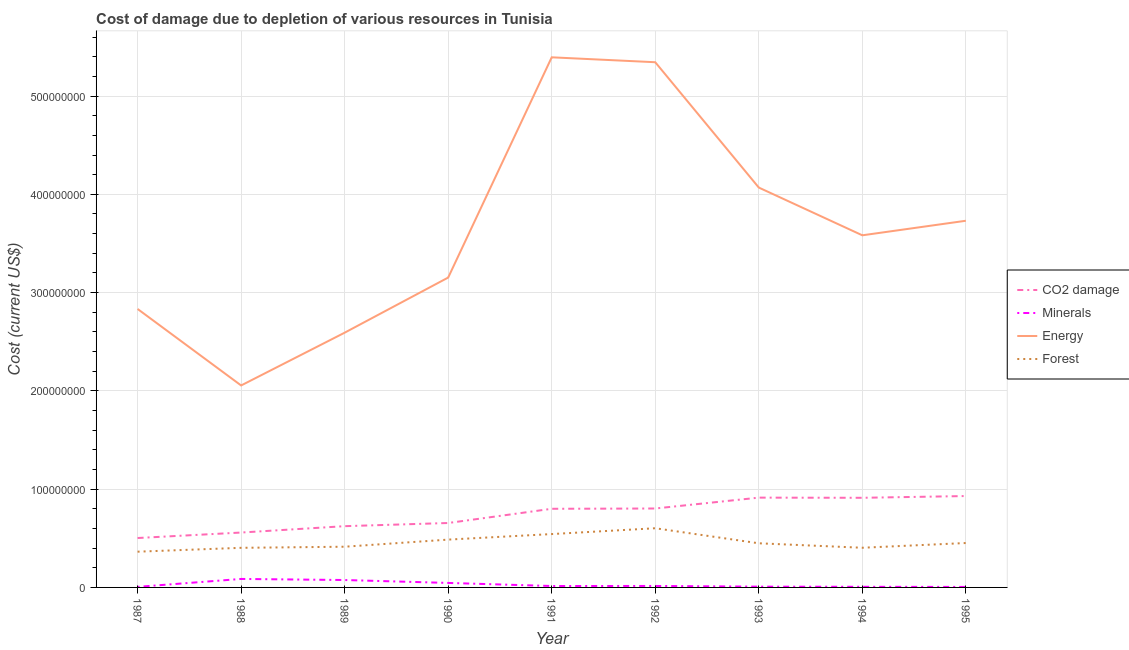Is the number of lines equal to the number of legend labels?
Give a very brief answer. Yes. What is the cost of damage due to depletion of coal in 1988?
Keep it short and to the point. 5.59e+07. Across all years, what is the maximum cost of damage due to depletion of energy?
Your answer should be very brief. 5.39e+08. Across all years, what is the minimum cost of damage due to depletion of coal?
Offer a very short reply. 5.03e+07. In which year was the cost of damage due to depletion of energy maximum?
Ensure brevity in your answer.  1991. In which year was the cost of damage due to depletion of forests minimum?
Provide a short and direct response. 1987. What is the total cost of damage due to depletion of minerals in the graph?
Give a very brief answer. 2.62e+07. What is the difference between the cost of damage due to depletion of coal in 1989 and that in 1995?
Make the answer very short. -3.07e+07. What is the difference between the cost of damage due to depletion of energy in 1989 and the cost of damage due to depletion of forests in 1993?
Provide a succinct answer. 2.14e+08. What is the average cost of damage due to depletion of forests per year?
Ensure brevity in your answer.  4.57e+07. In the year 1995, what is the difference between the cost of damage due to depletion of coal and cost of damage due to depletion of minerals?
Your answer should be compact. 9.25e+07. What is the ratio of the cost of damage due to depletion of minerals in 1989 to that in 1990?
Provide a short and direct response. 1.65. Is the cost of damage due to depletion of forests in 1987 less than that in 1992?
Your answer should be very brief. Yes. Is the difference between the cost of damage due to depletion of energy in 1992 and 1994 greater than the difference between the cost of damage due to depletion of coal in 1992 and 1994?
Make the answer very short. Yes. What is the difference between the highest and the second highest cost of damage due to depletion of coal?
Offer a very short reply. 1.61e+06. What is the difference between the highest and the lowest cost of damage due to depletion of forests?
Your answer should be compact. 2.39e+07. Is it the case that in every year, the sum of the cost of damage due to depletion of coal and cost of damage due to depletion of energy is greater than the sum of cost of damage due to depletion of minerals and cost of damage due to depletion of forests?
Your response must be concise. Yes. Is it the case that in every year, the sum of the cost of damage due to depletion of coal and cost of damage due to depletion of minerals is greater than the cost of damage due to depletion of energy?
Give a very brief answer. No. Does the cost of damage due to depletion of minerals monotonically increase over the years?
Your answer should be very brief. No. Is the cost of damage due to depletion of forests strictly less than the cost of damage due to depletion of energy over the years?
Provide a short and direct response. Yes. How many lines are there?
Ensure brevity in your answer.  4. What is the difference between two consecutive major ticks on the Y-axis?
Provide a short and direct response. 1.00e+08. Are the values on the major ticks of Y-axis written in scientific E-notation?
Your answer should be very brief. No. Does the graph contain grids?
Provide a succinct answer. Yes. How many legend labels are there?
Provide a succinct answer. 4. What is the title of the graph?
Make the answer very short. Cost of damage due to depletion of various resources in Tunisia . Does "France" appear as one of the legend labels in the graph?
Provide a succinct answer. No. What is the label or title of the X-axis?
Make the answer very short. Year. What is the label or title of the Y-axis?
Your answer should be very brief. Cost (current US$). What is the Cost (current US$) in CO2 damage in 1987?
Provide a succinct answer. 5.03e+07. What is the Cost (current US$) in Minerals in 1987?
Make the answer very short. 5.67e+05. What is the Cost (current US$) in Energy in 1987?
Provide a succinct answer. 2.83e+08. What is the Cost (current US$) in Forest in 1987?
Your answer should be compact. 3.64e+07. What is the Cost (current US$) in CO2 damage in 1988?
Provide a succinct answer. 5.59e+07. What is the Cost (current US$) of Minerals in 1988?
Offer a terse response. 8.63e+06. What is the Cost (current US$) in Energy in 1988?
Your response must be concise. 2.06e+08. What is the Cost (current US$) of Forest in 1988?
Your response must be concise. 4.03e+07. What is the Cost (current US$) of CO2 damage in 1989?
Offer a very short reply. 6.23e+07. What is the Cost (current US$) of Minerals in 1989?
Provide a succinct answer. 7.53e+06. What is the Cost (current US$) in Energy in 1989?
Your answer should be very brief. 2.59e+08. What is the Cost (current US$) of Forest in 1989?
Your answer should be very brief. 4.14e+07. What is the Cost (current US$) of CO2 damage in 1990?
Offer a very short reply. 6.56e+07. What is the Cost (current US$) of Minerals in 1990?
Offer a terse response. 4.58e+06. What is the Cost (current US$) in Energy in 1990?
Your response must be concise. 3.15e+08. What is the Cost (current US$) in Forest in 1990?
Offer a terse response. 4.87e+07. What is the Cost (current US$) of CO2 damage in 1991?
Your answer should be compact. 8.00e+07. What is the Cost (current US$) in Minerals in 1991?
Keep it short and to the point. 1.44e+06. What is the Cost (current US$) in Energy in 1991?
Ensure brevity in your answer.  5.39e+08. What is the Cost (current US$) of Forest in 1991?
Your answer should be very brief. 5.43e+07. What is the Cost (current US$) in CO2 damage in 1992?
Make the answer very short. 8.03e+07. What is the Cost (current US$) in Minerals in 1992?
Make the answer very short. 1.50e+06. What is the Cost (current US$) of Energy in 1992?
Provide a short and direct response. 5.34e+08. What is the Cost (current US$) in Forest in 1992?
Keep it short and to the point. 6.02e+07. What is the Cost (current US$) in CO2 damage in 1993?
Your answer should be compact. 9.14e+07. What is the Cost (current US$) of Minerals in 1993?
Give a very brief answer. 7.94e+05. What is the Cost (current US$) of Energy in 1993?
Offer a very short reply. 4.07e+08. What is the Cost (current US$) in Forest in 1993?
Ensure brevity in your answer.  4.49e+07. What is the Cost (current US$) of CO2 damage in 1994?
Your answer should be compact. 9.12e+07. What is the Cost (current US$) of Minerals in 1994?
Make the answer very short. 6.46e+05. What is the Cost (current US$) in Energy in 1994?
Offer a very short reply. 3.58e+08. What is the Cost (current US$) in Forest in 1994?
Offer a very short reply. 4.04e+07. What is the Cost (current US$) of CO2 damage in 1995?
Your answer should be compact. 9.30e+07. What is the Cost (current US$) of Minerals in 1995?
Ensure brevity in your answer.  5.07e+05. What is the Cost (current US$) of Energy in 1995?
Provide a succinct answer. 3.73e+08. What is the Cost (current US$) of Forest in 1995?
Offer a terse response. 4.52e+07. Across all years, what is the maximum Cost (current US$) in CO2 damage?
Your response must be concise. 9.30e+07. Across all years, what is the maximum Cost (current US$) of Minerals?
Keep it short and to the point. 8.63e+06. Across all years, what is the maximum Cost (current US$) in Energy?
Ensure brevity in your answer.  5.39e+08. Across all years, what is the maximum Cost (current US$) of Forest?
Ensure brevity in your answer.  6.02e+07. Across all years, what is the minimum Cost (current US$) in CO2 damage?
Your response must be concise. 5.03e+07. Across all years, what is the minimum Cost (current US$) in Minerals?
Your response must be concise. 5.07e+05. Across all years, what is the minimum Cost (current US$) of Energy?
Make the answer very short. 2.06e+08. Across all years, what is the minimum Cost (current US$) of Forest?
Your answer should be very brief. 3.64e+07. What is the total Cost (current US$) of CO2 damage in the graph?
Provide a short and direct response. 6.70e+08. What is the total Cost (current US$) of Minerals in the graph?
Give a very brief answer. 2.62e+07. What is the total Cost (current US$) of Energy in the graph?
Offer a terse response. 3.28e+09. What is the total Cost (current US$) in Forest in the graph?
Provide a short and direct response. 4.12e+08. What is the difference between the Cost (current US$) of CO2 damage in 1987 and that in 1988?
Give a very brief answer. -5.58e+06. What is the difference between the Cost (current US$) of Minerals in 1987 and that in 1988?
Provide a succinct answer. -8.07e+06. What is the difference between the Cost (current US$) of Energy in 1987 and that in 1988?
Your response must be concise. 7.78e+07. What is the difference between the Cost (current US$) of Forest in 1987 and that in 1988?
Give a very brief answer. -3.94e+06. What is the difference between the Cost (current US$) in CO2 damage in 1987 and that in 1989?
Make the answer very short. -1.21e+07. What is the difference between the Cost (current US$) in Minerals in 1987 and that in 1989?
Make the answer very short. -6.97e+06. What is the difference between the Cost (current US$) of Energy in 1987 and that in 1989?
Keep it short and to the point. 2.41e+07. What is the difference between the Cost (current US$) of Forest in 1987 and that in 1989?
Your response must be concise. -5.05e+06. What is the difference between the Cost (current US$) of CO2 damage in 1987 and that in 1990?
Provide a short and direct response. -1.53e+07. What is the difference between the Cost (current US$) of Minerals in 1987 and that in 1990?
Your response must be concise. -4.01e+06. What is the difference between the Cost (current US$) in Energy in 1987 and that in 1990?
Provide a short and direct response. -3.19e+07. What is the difference between the Cost (current US$) of Forest in 1987 and that in 1990?
Make the answer very short. -1.23e+07. What is the difference between the Cost (current US$) of CO2 damage in 1987 and that in 1991?
Make the answer very short. -2.97e+07. What is the difference between the Cost (current US$) in Minerals in 1987 and that in 1991?
Your response must be concise. -8.71e+05. What is the difference between the Cost (current US$) in Energy in 1987 and that in 1991?
Give a very brief answer. -2.56e+08. What is the difference between the Cost (current US$) of Forest in 1987 and that in 1991?
Provide a succinct answer. -1.79e+07. What is the difference between the Cost (current US$) of CO2 damage in 1987 and that in 1992?
Keep it short and to the point. -3.00e+07. What is the difference between the Cost (current US$) in Minerals in 1987 and that in 1992?
Give a very brief answer. -9.30e+05. What is the difference between the Cost (current US$) of Energy in 1987 and that in 1992?
Ensure brevity in your answer.  -2.51e+08. What is the difference between the Cost (current US$) in Forest in 1987 and that in 1992?
Offer a very short reply. -2.39e+07. What is the difference between the Cost (current US$) of CO2 damage in 1987 and that in 1993?
Give a very brief answer. -4.11e+07. What is the difference between the Cost (current US$) in Minerals in 1987 and that in 1993?
Make the answer very short. -2.27e+05. What is the difference between the Cost (current US$) of Energy in 1987 and that in 1993?
Ensure brevity in your answer.  -1.24e+08. What is the difference between the Cost (current US$) of Forest in 1987 and that in 1993?
Your answer should be very brief. -8.55e+06. What is the difference between the Cost (current US$) of CO2 damage in 1987 and that in 1994?
Offer a terse response. -4.09e+07. What is the difference between the Cost (current US$) in Minerals in 1987 and that in 1994?
Offer a terse response. -7.91e+04. What is the difference between the Cost (current US$) of Energy in 1987 and that in 1994?
Your answer should be very brief. -7.49e+07. What is the difference between the Cost (current US$) in Forest in 1987 and that in 1994?
Provide a succinct answer. -4.00e+06. What is the difference between the Cost (current US$) in CO2 damage in 1987 and that in 1995?
Keep it short and to the point. -4.27e+07. What is the difference between the Cost (current US$) of Minerals in 1987 and that in 1995?
Make the answer very short. 5.98e+04. What is the difference between the Cost (current US$) in Energy in 1987 and that in 1995?
Ensure brevity in your answer.  -8.97e+07. What is the difference between the Cost (current US$) of Forest in 1987 and that in 1995?
Give a very brief answer. -8.82e+06. What is the difference between the Cost (current US$) in CO2 damage in 1988 and that in 1989?
Give a very brief answer. -6.48e+06. What is the difference between the Cost (current US$) of Minerals in 1988 and that in 1989?
Make the answer very short. 1.10e+06. What is the difference between the Cost (current US$) of Energy in 1988 and that in 1989?
Provide a short and direct response. -5.37e+07. What is the difference between the Cost (current US$) of Forest in 1988 and that in 1989?
Provide a succinct answer. -1.12e+06. What is the difference between the Cost (current US$) of CO2 damage in 1988 and that in 1990?
Your answer should be compact. -9.71e+06. What is the difference between the Cost (current US$) of Minerals in 1988 and that in 1990?
Provide a succinct answer. 4.05e+06. What is the difference between the Cost (current US$) in Energy in 1988 and that in 1990?
Provide a succinct answer. -1.10e+08. What is the difference between the Cost (current US$) in Forest in 1988 and that in 1990?
Your response must be concise. -8.35e+06. What is the difference between the Cost (current US$) of CO2 damage in 1988 and that in 1991?
Ensure brevity in your answer.  -2.42e+07. What is the difference between the Cost (current US$) of Minerals in 1988 and that in 1991?
Your response must be concise. 7.19e+06. What is the difference between the Cost (current US$) in Energy in 1988 and that in 1991?
Your response must be concise. -3.34e+08. What is the difference between the Cost (current US$) in Forest in 1988 and that in 1991?
Your response must be concise. -1.40e+07. What is the difference between the Cost (current US$) in CO2 damage in 1988 and that in 1992?
Your answer should be very brief. -2.45e+07. What is the difference between the Cost (current US$) of Minerals in 1988 and that in 1992?
Keep it short and to the point. 7.14e+06. What is the difference between the Cost (current US$) in Energy in 1988 and that in 1992?
Provide a short and direct response. -3.29e+08. What is the difference between the Cost (current US$) in Forest in 1988 and that in 1992?
Provide a short and direct response. -1.99e+07. What is the difference between the Cost (current US$) in CO2 damage in 1988 and that in 1993?
Make the answer very short. -3.55e+07. What is the difference between the Cost (current US$) in Minerals in 1988 and that in 1993?
Give a very brief answer. 7.84e+06. What is the difference between the Cost (current US$) in Energy in 1988 and that in 1993?
Ensure brevity in your answer.  -2.01e+08. What is the difference between the Cost (current US$) in Forest in 1988 and that in 1993?
Provide a succinct answer. -4.61e+06. What is the difference between the Cost (current US$) of CO2 damage in 1988 and that in 1994?
Provide a short and direct response. -3.54e+07. What is the difference between the Cost (current US$) in Minerals in 1988 and that in 1994?
Keep it short and to the point. 7.99e+06. What is the difference between the Cost (current US$) of Energy in 1988 and that in 1994?
Your answer should be very brief. -1.53e+08. What is the difference between the Cost (current US$) in Forest in 1988 and that in 1994?
Provide a succinct answer. -6.18e+04. What is the difference between the Cost (current US$) of CO2 damage in 1988 and that in 1995?
Offer a very short reply. -3.71e+07. What is the difference between the Cost (current US$) of Minerals in 1988 and that in 1995?
Your answer should be very brief. 8.13e+06. What is the difference between the Cost (current US$) in Energy in 1988 and that in 1995?
Your answer should be very brief. -1.68e+08. What is the difference between the Cost (current US$) of Forest in 1988 and that in 1995?
Give a very brief answer. -4.88e+06. What is the difference between the Cost (current US$) of CO2 damage in 1989 and that in 1990?
Ensure brevity in your answer.  -3.23e+06. What is the difference between the Cost (current US$) of Minerals in 1989 and that in 1990?
Your answer should be very brief. 2.96e+06. What is the difference between the Cost (current US$) in Energy in 1989 and that in 1990?
Offer a terse response. -5.61e+07. What is the difference between the Cost (current US$) of Forest in 1989 and that in 1990?
Offer a very short reply. -7.24e+06. What is the difference between the Cost (current US$) of CO2 damage in 1989 and that in 1991?
Your response must be concise. -1.77e+07. What is the difference between the Cost (current US$) in Minerals in 1989 and that in 1991?
Provide a succinct answer. 6.10e+06. What is the difference between the Cost (current US$) in Energy in 1989 and that in 1991?
Provide a succinct answer. -2.80e+08. What is the difference between the Cost (current US$) in Forest in 1989 and that in 1991?
Your answer should be very brief. -1.29e+07. What is the difference between the Cost (current US$) of CO2 damage in 1989 and that in 1992?
Make the answer very short. -1.80e+07. What is the difference between the Cost (current US$) in Minerals in 1989 and that in 1992?
Make the answer very short. 6.04e+06. What is the difference between the Cost (current US$) in Energy in 1989 and that in 1992?
Your answer should be very brief. -2.75e+08. What is the difference between the Cost (current US$) in Forest in 1989 and that in 1992?
Make the answer very short. -1.88e+07. What is the difference between the Cost (current US$) in CO2 damage in 1989 and that in 1993?
Provide a succinct answer. -2.90e+07. What is the difference between the Cost (current US$) in Minerals in 1989 and that in 1993?
Offer a very short reply. 6.74e+06. What is the difference between the Cost (current US$) of Energy in 1989 and that in 1993?
Give a very brief answer. -1.48e+08. What is the difference between the Cost (current US$) in Forest in 1989 and that in 1993?
Your answer should be compact. -3.50e+06. What is the difference between the Cost (current US$) of CO2 damage in 1989 and that in 1994?
Make the answer very short. -2.89e+07. What is the difference between the Cost (current US$) of Minerals in 1989 and that in 1994?
Provide a succinct answer. 6.89e+06. What is the difference between the Cost (current US$) of Energy in 1989 and that in 1994?
Offer a terse response. -9.91e+07. What is the difference between the Cost (current US$) in Forest in 1989 and that in 1994?
Offer a very short reply. 1.05e+06. What is the difference between the Cost (current US$) in CO2 damage in 1989 and that in 1995?
Make the answer very short. -3.07e+07. What is the difference between the Cost (current US$) of Minerals in 1989 and that in 1995?
Give a very brief answer. 7.03e+06. What is the difference between the Cost (current US$) of Energy in 1989 and that in 1995?
Provide a succinct answer. -1.14e+08. What is the difference between the Cost (current US$) of Forest in 1989 and that in 1995?
Offer a very short reply. -3.77e+06. What is the difference between the Cost (current US$) in CO2 damage in 1990 and that in 1991?
Provide a short and direct response. -1.45e+07. What is the difference between the Cost (current US$) of Minerals in 1990 and that in 1991?
Offer a very short reply. 3.14e+06. What is the difference between the Cost (current US$) of Energy in 1990 and that in 1991?
Offer a very short reply. -2.24e+08. What is the difference between the Cost (current US$) of Forest in 1990 and that in 1991?
Give a very brief answer. -5.64e+06. What is the difference between the Cost (current US$) in CO2 damage in 1990 and that in 1992?
Give a very brief answer. -1.48e+07. What is the difference between the Cost (current US$) in Minerals in 1990 and that in 1992?
Offer a terse response. 3.08e+06. What is the difference between the Cost (current US$) of Energy in 1990 and that in 1992?
Your answer should be compact. -2.19e+08. What is the difference between the Cost (current US$) in Forest in 1990 and that in 1992?
Ensure brevity in your answer.  -1.16e+07. What is the difference between the Cost (current US$) in CO2 damage in 1990 and that in 1993?
Keep it short and to the point. -2.58e+07. What is the difference between the Cost (current US$) in Minerals in 1990 and that in 1993?
Offer a terse response. 3.78e+06. What is the difference between the Cost (current US$) of Energy in 1990 and that in 1993?
Your answer should be compact. -9.16e+07. What is the difference between the Cost (current US$) of Forest in 1990 and that in 1993?
Offer a very short reply. 3.74e+06. What is the difference between the Cost (current US$) in CO2 damage in 1990 and that in 1994?
Ensure brevity in your answer.  -2.56e+07. What is the difference between the Cost (current US$) in Minerals in 1990 and that in 1994?
Ensure brevity in your answer.  3.93e+06. What is the difference between the Cost (current US$) of Energy in 1990 and that in 1994?
Your answer should be very brief. -4.30e+07. What is the difference between the Cost (current US$) of Forest in 1990 and that in 1994?
Keep it short and to the point. 8.29e+06. What is the difference between the Cost (current US$) of CO2 damage in 1990 and that in 1995?
Ensure brevity in your answer.  -2.74e+07. What is the difference between the Cost (current US$) in Minerals in 1990 and that in 1995?
Your answer should be very brief. 4.07e+06. What is the difference between the Cost (current US$) of Energy in 1990 and that in 1995?
Make the answer very short. -5.78e+07. What is the difference between the Cost (current US$) of Forest in 1990 and that in 1995?
Your answer should be very brief. 3.47e+06. What is the difference between the Cost (current US$) in CO2 damage in 1991 and that in 1992?
Provide a succinct answer. -2.96e+05. What is the difference between the Cost (current US$) of Minerals in 1991 and that in 1992?
Your response must be concise. -5.93e+04. What is the difference between the Cost (current US$) in Energy in 1991 and that in 1992?
Your answer should be very brief. 5.01e+06. What is the difference between the Cost (current US$) in Forest in 1991 and that in 1992?
Your answer should be very brief. -5.92e+06. What is the difference between the Cost (current US$) of CO2 damage in 1991 and that in 1993?
Your answer should be very brief. -1.14e+07. What is the difference between the Cost (current US$) of Minerals in 1991 and that in 1993?
Provide a short and direct response. 6.44e+05. What is the difference between the Cost (current US$) in Energy in 1991 and that in 1993?
Offer a terse response. 1.33e+08. What is the difference between the Cost (current US$) in Forest in 1991 and that in 1993?
Give a very brief answer. 9.38e+06. What is the difference between the Cost (current US$) of CO2 damage in 1991 and that in 1994?
Offer a terse response. -1.12e+07. What is the difference between the Cost (current US$) in Minerals in 1991 and that in 1994?
Make the answer very short. 7.91e+05. What is the difference between the Cost (current US$) of Energy in 1991 and that in 1994?
Your answer should be compact. 1.81e+08. What is the difference between the Cost (current US$) of Forest in 1991 and that in 1994?
Provide a succinct answer. 1.39e+07. What is the difference between the Cost (current US$) of CO2 damage in 1991 and that in 1995?
Your answer should be very brief. -1.30e+07. What is the difference between the Cost (current US$) in Minerals in 1991 and that in 1995?
Your answer should be compact. 9.30e+05. What is the difference between the Cost (current US$) of Energy in 1991 and that in 1995?
Give a very brief answer. 1.66e+08. What is the difference between the Cost (current US$) in Forest in 1991 and that in 1995?
Your answer should be very brief. 9.11e+06. What is the difference between the Cost (current US$) in CO2 damage in 1992 and that in 1993?
Your answer should be very brief. -1.11e+07. What is the difference between the Cost (current US$) of Minerals in 1992 and that in 1993?
Offer a very short reply. 7.03e+05. What is the difference between the Cost (current US$) in Energy in 1992 and that in 1993?
Your answer should be very brief. 1.28e+08. What is the difference between the Cost (current US$) in Forest in 1992 and that in 1993?
Ensure brevity in your answer.  1.53e+07. What is the difference between the Cost (current US$) of CO2 damage in 1992 and that in 1994?
Provide a short and direct response. -1.09e+07. What is the difference between the Cost (current US$) in Minerals in 1992 and that in 1994?
Keep it short and to the point. 8.51e+05. What is the difference between the Cost (current US$) in Energy in 1992 and that in 1994?
Offer a very short reply. 1.76e+08. What is the difference between the Cost (current US$) of Forest in 1992 and that in 1994?
Make the answer very short. 1.99e+07. What is the difference between the Cost (current US$) of CO2 damage in 1992 and that in 1995?
Your answer should be compact. -1.27e+07. What is the difference between the Cost (current US$) of Minerals in 1992 and that in 1995?
Make the answer very short. 9.90e+05. What is the difference between the Cost (current US$) in Energy in 1992 and that in 1995?
Make the answer very short. 1.61e+08. What is the difference between the Cost (current US$) in Forest in 1992 and that in 1995?
Make the answer very short. 1.50e+07. What is the difference between the Cost (current US$) of CO2 damage in 1993 and that in 1994?
Make the answer very short. 1.69e+05. What is the difference between the Cost (current US$) in Minerals in 1993 and that in 1994?
Keep it short and to the point. 1.48e+05. What is the difference between the Cost (current US$) in Energy in 1993 and that in 1994?
Your answer should be compact. 4.86e+07. What is the difference between the Cost (current US$) of Forest in 1993 and that in 1994?
Provide a succinct answer. 4.55e+06. What is the difference between the Cost (current US$) of CO2 damage in 1993 and that in 1995?
Ensure brevity in your answer.  -1.61e+06. What is the difference between the Cost (current US$) in Minerals in 1993 and that in 1995?
Provide a short and direct response. 2.87e+05. What is the difference between the Cost (current US$) of Energy in 1993 and that in 1995?
Keep it short and to the point. 3.38e+07. What is the difference between the Cost (current US$) of Forest in 1993 and that in 1995?
Make the answer very short. -2.73e+05. What is the difference between the Cost (current US$) of CO2 damage in 1994 and that in 1995?
Ensure brevity in your answer.  -1.78e+06. What is the difference between the Cost (current US$) in Minerals in 1994 and that in 1995?
Your response must be concise. 1.39e+05. What is the difference between the Cost (current US$) in Energy in 1994 and that in 1995?
Provide a succinct answer. -1.48e+07. What is the difference between the Cost (current US$) in Forest in 1994 and that in 1995?
Offer a very short reply. -4.82e+06. What is the difference between the Cost (current US$) of CO2 damage in 1987 and the Cost (current US$) of Minerals in 1988?
Provide a short and direct response. 4.16e+07. What is the difference between the Cost (current US$) in CO2 damage in 1987 and the Cost (current US$) in Energy in 1988?
Give a very brief answer. -1.55e+08. What is the difference between the Cost (current US$) of CO2 damage in 1987 and the Cost (current US$) of Forest in 1988?
Keep it short and to the point. 9.97e+06. What is the difference between the Cost (current US$) of Minerals in 1987 and the Cost (current US$) of Energy in 1988?
Your answer should be very brief. -2.05e+08. What is the difference between the Cost (current US$) of Minerals in 1987 and the Cost (current US$) of Forest in 1988?
Give a very brief answer. -3.97e+07. What is the difference between the Cost (current US$) in Energy in 1987 and the Cost (current US$) in Forest in 1988?
Offer a terse response. 2.43e+08. What is the difference between the Cost (current US$) in CO2 damage in 1987 and the Cost (current US$) in Minerals in 1989?
Provide a succinct answer. 4.27e+07. What is the difference between the Cost (current US$) in CO2 damage in 1987 and the Cost (current US$) in Energy in 1989?
Provide a succinct answer. -2.09e+08. What is the difference between the Cost (current US$) of CO2 damage in 1987 and the Cost (current US$) of Forest in 1989?
Make the answer very short. 8.85e+06. What is the difference between the Cost (current US$) in Minerals in 1987 and the Cost (current US$) in Energy in 1989?
Give a very brief answer. -2.59e+08. What is the difference between the Cost (current US$) in Minerals in 1987 and the Cost (current US$) in Forest in 1989?
Your answer should be compact. -4.09e+07. What is the difference between the Cost (current US$) of Energy in 1987 and the Cost (current US$) of Forest in 1989?
Your answer should be very brief. 2.42e+08. What is the difference between the Cost (current US$) in CO2 damage in 1987 and the Cost (current US$) in Minerals in 1990?
Ensure brevity in your answer.  4.57e+07. What is the difference between the Cost (current US$) in CO2 damage in 1987 and the Cost (current US$) in Energy in 1990?
Your answer should be compact. -2.65e+08. What is the difference between the Cost (current US$) of CO2 damage in 1987 and the Cost (current US$) of Forest in 1990?
Provide a short and direct response. 1.62e+06. What is the difference between the Cost (current US$) of Minerals in 1987 and the Cost (current US$) of Energy in 1990?
Offer a terse response. -3.15e+08. What is the difference between the Cost (current US$) of Minerals in 1987 and the Cost (current US$) of Forest in 1990?
Provide a succinct answer. -4.81e+07. What is the difference between the Cost (current US$) in Energy in 1987 and the Cost (current US$) in Forest in 1990?
Your response must be concise. 2.35e+08. What is the difference between the Cost (current US$) in CO2 damage in 1987 and the Cost (current US$) in Minerals in 1991?
Your answer should be compact. 4.88e+07. What is the difference between the Cost (current US$) of CO2 damage in 1987 and the Cost (current US$) of Energy in 1991?
Offer a terse response. -4.89e+08. What is the difference between the Cost (current US$) in CO2 damage in 1987 and the Cost (current US$) in Forest in 1991?
Offer a terse response. -4.02e+06. What is the difference between the Cost (current US$) of Minerals in 1987 and the Cost (current US$) of Energy in 1991?
Keep it short and to the point. -5.39e+08. What is the difference between the Cost (current US$) in Minerals in 1987 and the Cost (current US$) in Forest in 1991?
Your response must be concise. -5.37e+07. What is the difference between the Cost (current US$) in Energy in 1987 and the Cost (current US$) in Forest in 1991?
Offer a very short reply. 2.29e+08. What is the difference between the Cost (current US$) in CO2 damage in 1987 and the Cost (current US$) in Minerals in 1992?
Make the answer very short. 4.88e+07. What is the difference between the Cost (current US$) in CO2 damage in 1987 and the Cost (current US$) in Energy in 1992?
Provide a succinct answer. -4.84e+08. What is the difference between the Cost (current US$) in CO2 damage in 1987 and the Cost (current US$) in Forest in 1992?
Provide a succinct answer. -9.95e+06. What is the difference between the Cost (current US$) in Minerals in 1987 and the Cost (current US$) in Energy in 1992?
Your answer should be very brief. -5.34e+08. What is the difference between the Cost (current US$) in Minerals in 1987 and the Cost (current US$) in Forest in 1992?
Provide a succinct answer. -5.97e+07. What is the difference between the Cost (current US$) of Energy in 1987 and the Cost (current US$) of Forest in 1992?
Provide a succinct answer. 2.23e+08. What is the difference between the Cost (current US$) of CO2 damage in 1987 and the Cost (current US$) of Minerals in 1993?
Give a very brief answer. 4.95e+07. What is the difference between the Cost (current US$) in CO2 damage in 1987 and the Cost (current US$) in Energy in 1993?
Your answer should be compact. -3.57e+08. What is the difference between the Cost (current US$) in CO2 damage in 1987 and the Cost (current US$) in Forest in 1993?
Offer a very short reply. 5.36e+06. What is the difference between the Cost (current US$) in Minerals in 1987 and the Cost (current US$) in Energy in 1993?
Provide a short and direct response. -4.06e+08. What is the difference between the Cost (current US$) in Minerals in 1987 and the Cost (current US$) in Forest in 1993?
Provide a succinct answer. -4.43e+07. What is the difference between the Cost (current US$) of Energy in 1987 and the Cost (current US$) of Forest in 1993?
Your answer should be very brief. 2.38e+08. What is the difference between the Cost (current US$) in CO2 damage in 1987 and the Cost (current US$) in Minerals in 1994?
Your answer should be very brief. 4.96e+07. What is the difference between the Cost (current US$) of CO2 damage in 1987 and the Cost (current US$) of Energy in 1994?
Provide a short and direct response. -3.08e+08. What is the difference between the Cost (current US$) of CO2 damage in 1987 and the Cost (current US$) of Forest in 1994?
Give a very brief answer. 9.91e+06. What is the difference between the Cost (current US$) of Minerals in 1987 and the Cost (current US$) of Energy in 1994?
Your answer should be very brief. -3.58e+08. What is the difference between the Cost (current US$) in Minerals in 1987 and the Cost (current US$) in Forest in 1994?
Your answer should be compact. -3.98e+07. What is the difference between the Cost (current US$) in Energy in 1987 and the Cost (current US$) in Forest in 1994?
Provide a short and direct response. 2.43e+08. What is the difference between the Cost (current US$) in CO2 damage in 1987 and the Cost (current US$) in Minerals in 1995?
Provide a short and direct response. 4.98e+07. What is the difference between the Cost (current US$) in CO2 damage in 1987 and the Cost (current US$) in Energy in 1995?
Offer a very short reply. -3.23e+08. What is the difference between the Cost (current US$) in CO2 damage in 1987 and the Cost (current US$) in Forest in 1995?
Give a very brief answer. 5.09e+06. What is the difference between the Cost (current US$) in Minerals in 1987 and the Cost (current US$) in Energy in 1995?
Offer a terse response. -3.73e+08. What is the difference between the Cost (current US$) of Minerals in 1987 and the Cost (current US$) of Forest in 1995?
Give a very brief answer. -4.46e+07. What is the difference between the Cost (current US$) in Energy in 1987 and the Cost (current US$) in Forest in 1995?
Offer a very short reply. 2.38e+08. What is the difference between the Cost (current US$) in CO2 damage in 1988 and the Cost (current US$) in Minerals in 1989?
Give a very brief answer. 4.83e+07. What is the difference between the Cost (current US$) of CO2 damage in 1988 and the Cost (current US$) of Energy in 1989?
Provide a short and direct response. -2.03e+08. What is the difference between the Cost (current US$) of CO2 damage in 1988 and the Cost (current US$) of Forest in 1989?
Provide a short and direct response. 1.44e+07. What is the difference between the Cost (current US$) of Minerals in 1988 and the Cost (current US$) of Energy in 1989?
Offer a very short reply. -2.51e+08. What is the difference between the Cost (current US$) in Minerals in 1988 and the Cost (current US$) in Forest in 1989?
Your response must be concise. -3.28e+07. What is the difference between the Cost (current US$) of Energy in 1988 and the Cost (current US$) of Forest in 1989?
Make the answer very short. 1.64e+08. What is the difference between the Cost (current US$) in CO2 damage in 1988 and the Cost (current US$) in Minerals in 1990?
Provide a short and direct response. 5.13e+07. What is the difference between the Cost (current US$) in CO2 damage in 1988 and the Cost (current US$) in Energy in 1990?
Provide a short and direct response. -2.59e+08. What is the difference between the Cost (current US$) of CO2 damage in 1988 and the Cost (current US$) of Forest in 1990?
Give a very brief answer. 7.19e+06. What is the difference between the Cost (current US$) of Minerals in 1988 and the Cost (current US$) of Energy in 1990?
Make the answer very short. -3.07e+08. What is the difference between the Cost (current US$) in Minerals in 1988 and the Cost (current US$) in Forest in 1990?
Ensure brevity in your answer.  -4.00e+07. What is the difference between the Cost (current US$) of Energy in 1988 and the Cost (current US$) of Forest in 1990?
Your answer should be compact. 1.57e+08. What is the difference between the Cost (current US$) in CO2 damage in 1988 and the Cost (current US$) in Minerals in 1991?
Provide a succinct answer. 5.44e+07. What is the difference between the Cost (current US$) of CO2 damage in 1988 and the Cost (current US$) of Energy in 1991?
Your answer should be compact. -4.84e+08. What is the difference between the Cost (current US$) in CO2 damage in 1988 and the Cost (current US$) in Forest in 1991?
Provide a short and direct response. 1.55e+06. What is the difference between the Cost (current US$) of Minerals in 1988 and the Cost (current US$) of Energy in 1991?
Provide a short and direct response. -5.31e+08. What is the difference between the Cost (current US$) of Minerals in 1988 and the Cost (current US$) of Forest in 1991?
Provide a short and direct response. -4.57e+07. What is the difference between the Cost (current US$) in Energy in 1988 and the Cost (current US$) in Forest in 1991?
Give a very brief answer. 1.51e+08. What is the difference between the Cost (current US$) in CO2 damage in 1988 and the Cost (current US$) in Minerals in 1992?
Your response must be concise. 5.44e+07. What is the difference between the Cost (current US$) of CO2 damage in 1988 and the Cost (current US$) of Energy in 1992?
Provide a short and direct response. -4.79e+08. What is the difference between the Cost (current US$) of CO2 damage in 1988 and the Cost (current US$) of Forest in 1992?
Provide a succinct answer. -4.37e+06. What is the difference between the Cost (current US$) of Minerals in 1988 and the Cost (current US$) of Energy in 1992?
Your answer should be compact. -5.26e+08. What is the difference between the Cost (current US$) in Minerals in 1988 and the Cost (current US$) in Forest in 1992?
Your answer should be compact. -5.16e+07. What is the difference between the Cost (current US$) in Energy in 1988 and the Cost (current US$) in Forest in 1992?
Give a very brief answer. 1.45e+08. What is the difference between the Cost (current US$) of CO2 damage in 1988 and the Cost (current US$) of Minerals in 1993?
Offer a terse response. 5.51e+07. What is the difference between the Cost (current US$) in CO2 damage in 1988 and the Cost (current US$) in Energy in 1993?
Your response must be concise. -3.51e+08. What is the difference between the Cost (current US$) of CO2 damage in 1988 and the Cost (current US$) of Forest in 1993?
Make the answer very short. 1.09e+07. What is the difference between the Cost (current US$) of Minerals in 1988 and the Cost (current US$) of Energy in 1993?
Give a very brief answer. -3.98e+08. What is the difference between the Cost (current US$) in Minerals in 1988 and the Cost (current US$) in Forest in 1993?
Offer a terse response. -3.63e+07. What is the difference between the Cost (current US$) of Energy in 1988 and the Cost (current US$) of Forest in 1993?
Your response must be concise. 1.61e+08. What is the difference between the Cost (current US$) in CO2 damage in 1988 and the Cost (current US$) in Minerals in 1994?
Your answer should be compact. 5.52e+07. What is the difference between the Cost (current US$) of CO2 damage in 1988 and the Cost (current US$) of Energy in 1994?
Make the answer very short. -3.02e+08. What is the difference between the Cost (current US$) in CO2 damage in 1988 and the Cost (current US$) in Forest in 1994?
Your response must be concise. 1.55e+07. What is the difference between the Cost (current US$) in Minerals in 1988 and the Cost (current US$) in Energy in 1994?
Your answer should be compact. -3.50e+08. What is the difference between the Cost (current US$) of Minerals in 1988 and the Cost (current US$) of Forest in 1994?
Your answer should be very brief. -3.17e+07. What is the difference between the Cost (current US$) of Energy in 1988 and the Cost (current US$) of Forest in 1994?
Your answer should be very brief. 1.65e+08. What is the difference between the Cost (current US$) in CO2 damage in 1988 and the Cost (current US$) in Minerals in 1995?
Your response must be concise. 5.53e+07. What is the difference between the Cost (current US$) of CO2 damage in 1988 and the Cost (current US$) of Energy in 1995?
Offer a terse response. -3.17e+08. What is the difference between the Cost (current US$) in CO2 damage in 1988 and the Cost (current US$) in Forest in 1995?
Ensure brevity in your answer.  1.07e+07. What is the difference between the Cost (current US$) in Minerals in 1988 and the Cost (current US$) in Energy in 1995?
Your response must be concise. -3.64e+08. What is the difference between the Cost (current US$) of Minerals in 1988 and the Cost (current US$) of Forest in 1995?
Your answer should be very brief. -3.66e+07. What is the difference between the Cost (current US$) of Energy in 1988 and the Cost (current US$) of Forest in 1995?
Give a very brief answer. 1.60e+08. What is the difference between the Cost (current US$) of CO2 damage in 1989 and the Cost (current US$) of Minerals in 1990?
Keep it short and to the point. 5.78e+07. What is the difference between the Cost (current US$) in CO2 damage in 1989 and the Cost (current US$) in Energy in 1990?
Make the answer very short. -2.53e+08. What is the difference between the Cost (current US$) of CO2 damage in 1989 and the Cost (current US$) of Forest in 1990?
Ensure brevity in your answer.  1.37e+07. What is the difference between the Cost (current US$) in Minerals in 1989 and the Cost (current US$) in Energy in 1990?
Make the answer very short. -3.08e+08. What is the difference between the Cost (current US$) of Minerals in 1989 and the Cost (current US$) of Forest in 1990?
Provide a succinct answer. -4.11e+07. What is the difference between the Cost (current US$) in Energy in 1989 and the Cost (current US$) in Forest in 1990?
Your answer should be very brief. 2.11e+08. What is the difference between the Cost (current US$) in CO2 damage in 1989 and the Cost (current US$) in Minerals in 1991?
Your answer should be very brief. 6.09e+07. What is the difference between the Cost (current US$) of CO2 damage in 1989 and the Cost (current US$) of Energy in 1991?
Give a very brief answer. -4.77e+08. What is the difference between the Cost (current US$) in CO2 damage in 1989 and the Cost (current US$) in Forest in 1991?
Give a very brief answer. 8.03e+06. What is the difference between the Cost (current US$) of Minerals in 1989 and the Cost (current US$) of Energy in 1991?
Offer a very short reply. -5.32e+08. What is the difference between the Cost (current US$) of Minerals in 1989 and the Cost (current US$) of Forest in 1991?
Your response must be concise. -4.68e+07. What is the difference between the Cost (current US$) of Energy in 1989 and the Cost (current US$) of Forest in 1991?
Provide a short and direct response. 2.05e+08. What is the difference between the Cost (current US$) of CO2 damage in 1989 and the Cost (current US$) of Minerals in 1992?
Make the answer very short. 6.08e+07. What is the difference between the Cost (current US$) of CO2 damage in 1989 and the Cost (current US$) of Energy in 1992?
Your answer should be compact. -4.72e+08. What is the difference between the Cost (current US$) in CO2 damage in 1989 and the Cost (current US$) in Forest in 1992?
Provide a short and direct response. 2.11e+06. What is the difference between the Cost (current US$) of Minerals in 1989 and the Cost (current US$) of Energy in 1992?
Ensure brevity in your answer.  -5.27e+08. What is the difference between the Cost (current US$) in Minerals in 1989 and the Cost (current US$) in Forest in 1992?
Give a very brief answer. -5.27e+07. What is the difference between the Cost (current US$) in Energy in 1989 and the Cost (current US$) in Forest in 1992?
Give a very brief answer. 1.99e+08. What is the difference between the Cost (current US$) of CO2 damage in 1989 and the Cost (current US$) of Minerals in 1993?
Offer a very short reply. 6.15e+07. What is the difference between the Cost (current US$) in CO2 damage in 1989 and the Cost (current US$) in Energy in 1993?
Keep it short and to the point. -3.45e+08. What is the difference between the Cost (current US$) of CO2 damage in 1989 and the Cost (current US$) of Forest in 1993?
Offer a terse response. 1.74e+07. What is the difference between the Cost (current US$) in Minerals in 1989 and the Cost (current US$) in Energy in 1993?
Provide a short and direct response. -3.99e+08. What is the difference between the Cost (current US$) of Minerals in 1989 and the Cost (current US$) of Forest in 1993?
Your response must be concise. -3.74e+07. What is the difference between the Cost (current US$) in Energy in 1989 and the Cost (current US$) in Forest in 1993?
Your answer should be compact. 2.14e+08. What is the difference between the Cost (current US$) of CO2 damage in 1989 and the Cost (current US$) of Minerals in 1994?
Offer a very short reply. 6.17e+07. What is the difference between the Cost (current US$) of CO2 damage in 1989 and the Cost (current US$) of Energy in 1994?
Ensure brevity in your answer.  -2.96e+08. What is the difference between the Cost (current US$) of CO2 damage in 1989 and the Cost (current US$) of Forest in 1994?
Offer a very short reply. 2.20e+07. What is the difference between the Cost (current US$) in Minerals in 1989 and the Cost (current US$) in Energy in 1994?
Ensure brevity in your answer.  -3.51e+08. What is the difference between the Cost (current US$) of Minerals in 1989 and the Cost (current US$) of Forest in 1994?
Give a very brief answer. -3.28e+07. What is the difference between the Cost (current US$) in Energy in 1989 and the Cost (current US$) in Forest in 1994?
Offer a terse response. 2.19e+08. What is the difference between the Cost (current US$) of CO2 damage in 1989 and the Cost (current US$) of Minerals in 1995?
Your answer should be compact. 6.18e+07. What is the difference between the Cost (current US$) of CO2 damage in 1989 and the Cost (current US$) of Energy in 1995?
Offer a very short reply. -3.11e+08. What is the difference between the Cost (current US$) of CO2 damage in 1989 and the Cost (current US$) of Forest in 1995?
Offer a terse response. 1.71e+07. What is the difference between the Cost (current US$) in Minerals in 1989 and the Cost (current US$) in Energy in 1995?
Provide a short and direct response. -3.66e+08. What is the difference between the Cost (current US$) of Minerals in 1989 and the Cost (current US$) of Forest in 1995?
Provide a short and direct response. -3.77e+07. What is the difference between the Cost (current US$) in Energy in 1989 and the Cost (current US$) in Forest in 1995?
Ensure brevity in your answer.  2.14e+08. What is the difference between the Cost (current US$) of CO2 damage in 1990 and the Cost (current US$) of Minerals in 1991?
Provide a succinct answer. 6.41e+07. What is the difference between the Cost (current US$) in CO2 damage in 1990 and the Cost (current US$) in Energy in 1991?
Offer a very short reply. -4.74e+08. What is the difference between the Cost (current US$) in CO2 damage in 1990 and the Cost (current US$) in Forest in 1991?
Keep it short and to the point. 1.13e+07. What is the difference between the Cost (current US$) of Minerals in 1990 and the Cost (current US$) of Energy in 1991?
Make the answer very short. -5.35e+08. What is the difference between the Cost (current US$) of Minerals in 1990 and the Cost (current US$) of Forest in 1991?
Your response must be concise. -4.97e+07. What is the difference between the Cost (current US$) of Energy in 1990 and the Cost (current US$) of Forest in 1991?
Your answer should be compact. 2.61e+08. What is the difference between the Cost (current US$) in CO2 damage in 1990 and the Cost (current US$) in Minerals in 1992?
Make the answer very short. 6.41e+07. What is the difference between the Cost (current US$) of CO2 damage in 1990 and the Cost (current US$) of Energy in 1992?
Your answer should be very brief. -4.69e+08. What is the difference between the Cost (current US$) of CO2 damage in 1990 and the Cost (current US$) of Forest in 1992?
Offer a very short reply. 5.34e+06. What is the difference between the Cost (current US$) in Minerals in 1990 and the Cost (current US$) in Energy in 1992?
Your response must be concise. -5.30e+08. What is the difference between the Cost (current US$) of Minerals in 1990 and the Cost (current US$) of Forest in 1992?
Your response must be concise. -5.56e+07. What is the difference between the Cost (current US$) in Energy in 1990 and the Cost (current US$) in Forest in 1992?
Make the answer very short. 2.55e+08. What is the difference between the Cost (current US$) in CO2 damage in 1990 and the Cost (current US$) in Minerals in 1993?
Make the answer very short. 6.48e+07. What is the difference between the Cost (current US$) of CO2 damage in 1990 and the Cost (current US$) of Energy in 1993?
Your answer should be compact. -3.41e+08. What is the difference between the Cost (current US$) of CO2 damage in 1990 and the Cost (current US$) of Forest in 1993?
Your answer should be very brief. 2.06e+07. What is the difference between the Cost (current US$) in Minerals in 1990 and the Cost (current US$) in Energy in 1993?
Keep it short and to the point. -4.02e+08. What is the difference between the Cost (current US$) in Minerals in 1990 and the Cost (current US$) in Forest in 1993?
Keep it short and to the point. -4.03e+07. What is the difference between the Cost (current US$) in Energy in 1990 and the Cost (current US$) in Forest in 1993?
Give a very brief answer. 2.70e+08. What is the difference between the Cost (current US$) in CO2 damage in 1990 and the Cost (current US$) in Minerals in 1994?
Ensure brevity in your answer.  6.49e+07. What is the difference between the Cost (current US$) of CO2 damage in 1990 and the Cost (current US$) of Energy in 1994?
Provide a short and direct response. -2.93e+08. What is the difference between the Cost (current US$) of CO2 damage in 1990 and the Cost (current US$) of Forest in 1994?
Your answer should be very brief. 2.52e+07. What is the difference between the Cost (current US$) in Minerals in 1990 and the Cost (current US$) in Energy in 1994?
Offer a very short reply. -3.54e+08. What is the difference between the Cost (current US$) in Minerals in 1990 and the Cost (current US$) in Forest in 1994?
Ensure brevity in your answer.  -3.58e+07. What is the difference between the Cost (current US$) in Energy in 1990 and the Cost (current US$) in Forest in 1994?
Offer a terse response. 2.75e+08. What is the difference between the Cost (current US$) of CO2 damage in 1990 and the Cost (current US$) of Minerals in 1995?
Give a very brief answer. 6.51e+07. What is the difference between the Cost (current US$) in CO2 damage in 1990 and the Cost (current US$) in Energy in 1995?
Your response must be concise. -3.08e+08. What is the difference between the Cost (current US$) in CO2 damage in 1990 and the Cost (current US$) in Forest in 1995?
Give a very brief answer. 2.04e+07. What is the difference between the Cost (current US$) in Minerals in 1990 and the Cost (current US$) in Energy in 1995?
Provide a succinct answer. -3.69e+08. What is the difference between the Cost (current US$) in Minerals in 1990 and the Cost (current US$) in Forest in 1995?
Your answer should be very brief. -4.06e+07. What is the difference between the Cost (current US$) in Energy in 1990 and the Cost (current US$) in Forest in 1995?
Ensure brevity in your answer.  2.70e+08. What is the difference between the Cost (current US$) of CO2 damage in 1991 and the Cost (current US$) of Minerals in 1992?
Keep it short and to the point. 7.85e+07. What is the difference between the Cost (current US$) of CO2 damage in 1991 and the Cost (current US$) of Energy in 1992?
Your response must be concise. -4.54e+08. What is the difference between the Cost (current US$) of CO2 damage in 1991 and the Cost (current US$) of Forest in 1992?
Give a very brief answer. 1.98e+07. What is the difference between the Cost (current US$) of Minerals in 1991 and the Cost (current US$) of Energy in 1992?
Offer a very short reply. -5.33e+08. What is the difference between the Cost (current US$) in Minerals in 1991 and the Cost (current US$) in Forest in 1992?
Ensure brevity in your answer.  -5.88e+07. What is the difference between the Cost (current US$) of Energy in 1991 and the Cost (current US$) of Forest in 1992?
Make the answer very short. 4.79e+08. What is the difference between the Cost (current US$) of CO2 damage in 1991 and the Cost (current US$) of Minerals in 1993?
Offer a very short reply. 7.92e+07. What is the difference between the Cost (current US$) of CO2 damage in 1991 and the Cost (current US$) of Energy in 1993?
Your answer should be compact. -3.27e+08. What is the difference between the Cost (current US$) of CO2 damage in 1991 and the Cost (current US$) of Forest in 1993?
Your answer should be very brief. 3.51e+07. What is the difference between the Cost (current US$) in Minerals in 1991 and the Cost (current US$) in Energy in 1993?
Ensure brevity in your answer.  -4.05e+08. What is the difference between the Cost (current US$) in Minerals in 1991 and the Cost (current US$) in Forest in 1993?
Make the answer very short. -4.35e+07. What is the difference between the Cost (current US$) in Energy in 1991 and the Cost (current US$) in Forest in 1993?
Offer a very short reply. 4.94e+08. What is the difference between the Cost (current US$) of CO2 damage in 1991 and the Cost (current US$) of Minerals in 1994?
Keep it short and to the point. 7.94e+07. What is the difference between the Cost (current US$) of CO2 damage in 1991 and the Cost (current US$) of Energy in 1994?
Make the answer very short. -2.78e+08. What is the difference between the Cost (current US$) in CO2 damage in 1991 and the Cost (current US$) in Forest in 1994?
Make the answer very short. 3.97e+07. What is the difference between the Cost (current US$) of Minerals in 1991 and the Cost (current US$) of Energy in 1994?
Give a very brief answer. -3.57e+08. What is the difference between the Cost (current US$) of Minerals in 1991 and the Cost (current US$) of Forest in 1994?
Offer a terse response. -3.89e+07. What is the difference between the Cost (current US$) in Energy in 1991 and the Cost (current US$) in Forest in 1994?
Provide a succinct answer. 4.99e+08. What is the difference between the Cost (current US$) of CO2 damage in 1991 and the Cost (current US$) of Minerals in 1995?
Offer a terse response. 7.95e+07. What is the difference between the Cost (current US$) of CO2 damage in 1991 and the Cost (current US$) of Energy in 1995?
Keep it short and to the point. -2.93e+08. What is the difference between the Cost (current US$) in CO2 damage in 1991 and the Cost (current US$) in Forest in 1995?
Give a very brief answer. 3.48e+07. What is the difference between the Cost (current US$) of Minerals in 1991 and the Cost (current US$) of Energy in 1995?
Make the answer very short. -3.72e+08. What is the difference between the Cost (current US$) of Minerals in 1991 and the Cost (current US$) of Forest in 1995?
Provide a short and direct response. -4.38e+07. What is the difference between the Cost (current US$) in Energy in 1991 and the Cost (current US$) in Forest in 1995?
Your answer should be very brief. 4.94e+08. What is the difference between the Cost (current US$) in CO2 damage in 1992 and the Cost (current US$) in Minerals in 1993?
Your answer should be compact. 7.95e+07. What is the difference between the Cost (current US$) in CO2 damage in 1992 and the Cost (current US$) in Energy in 1993?
Ensure brevity in your answer.  -3.27e+08. What is the difference between the Cost (current US$) of CO2 damage in 1992 and the Cost (current US$) of Forest in 1993?
Give a very brief answer. 3.54e+07. What is the difference between the Cost (current US$) of Minerals in 1992 and the Cost (current US$) of Energy in 1993?
Ensure brevity in your answer.  -4.05e+08. What is the difference between the Cost (current US$) in Minerals in 1992 and the Cost (current US$) in Forest in 1993?
Your answer should be very brief. -4.34e+07. What is the difference between the Cost (current US$) of Energy in 1992 and the Cost (current US$) of Forest in 1993?
Provide a short and direct response. 4.89e+08. What is the difference between the Cost (current US$) of CO2 damage in 1992 and the Cost (current US$) of Minerals in 1994?
Your answer should be very brief. 7.97e+07. What is the difference between the Cost (current US$) of CO2 damage in 1992 and the Cost (current US$) of Energy in 1994?
Your answer should be very brief. -2.78e+08. What is the difference between the Cost (current US$) in CO2 damage in 1992 and the Cost (current US$) in Forest in 1994?
Provide a short and direct response. 3.99e+07. What is the difference between the Cost (current US$) of Minerals in 1992 and the Cost (current US$) of Energy in 1994?
Give a very brief answer. -3.57e+08. What is the difference between the Cost (current US$) in Minerals in 1992 and the Cost (current US$) in Forest in 1994?
Provide a short and direct response. -3.89e+07. What is the difference between the Cost (current US$) of Energy in 1992 and the Cost (current US$) of Forest in 1994?
Give a very brief answer. 4.94e+08. What is the difference between the Cost (current US$) of CO2 damage in 1992 and the Cost (current US$) of Minerals in 1995?
Your answer should be very brief. 7.98e+07. What is the difference between the Cost (current US$) of CO2 damage in 1992 and the Cost (current US$) of Energy in 1995?
Your response must be concise. -2.93e+08. What is the difference between the Cost (current US$) in CO2 damage in 1992 and the Cost (current US$) in Forest in 1995?
Provide a succinct answer. 3.51e+07. What is the difference between the Cost (current US$) in Minerals in 1992 and the Cost (current US$) in Energy in 1995?
Offer a very short reply. -3.72e+08. What is the difference between the Cost (current US$) of Minerals in 1992 and the Cost (current US$) of Forest in 1995?
Ensure brevity in your answer.  -4.37e+07. What is the difference between the Cost (current US$) of Energy in 1992 and the Cost (current US$) of Forest in 1995?
Your answer should be compact. 4.89e+08. What is the difference between the Cost (current US$) in CO2 damage in 1993 and the Cost (current US$) in Minerals in 1994?
Keep it short and to the point. 9.07e+07. What is the difference between the Cost (current US$) of CO2 damage in 1993 and the Cost (current US$) of Energy in 1994?
Ensure brevity in your answer.  -2.67e+08. What is the difference between the Cost (current US$) in CO2 damage in 1993 and the Cost (current US$) in Forest in 1994?
Your response must be concise. 5.10e+07. What is the difference between the Cost (current US$) in Minerals in 1993 and the Cost (current US$) in Energy in 1994?
Your answer should be very brief. -3.57e+08. What is the difference between the Cost (current US$) of Minerals in 1993 and the Cost (current US$) of Forest in 1994?
Make the answer very short. -3.96e+07. What is the difference between the Cost (current US$) in Energy in 1993 and the Cost (current US$) in Forest in 1994?
Offer a terse response. 3.67e+08. What is the difference between the Cost (current US$) in CO2 damage in 1993 and the Cost (current US$) in Minerals in 1995?
Your answer should be very brief. 9.09e+07. What is the difference between the Cost (current US$) of CO2 damage in 1993 and the Cost (current US$) of Energy in 1995?
Provide a succinct answer. -2.82e+08. What is the difference between the Cost (current US$) of CO2 damage in 1993 and the Cost (current US$) of Forest in 1995?
Offer a very short reply. 4.62e+07. What is the difference between the Cost (current US$) of Minerals in 1993 and the Cost (current US$) of Energy in 1995?
Keep it short and to the point. -3.72e+08. What is the difference between the Cost (current US$) in Minerals in 1993 and the Cost (current US$) in Forest in 1995?
Your response must be concise. -4.44e+07. What is the difference between the Cost (current US$) of Energy in 1993 and the Cost (current US$) of Forest in 1995?
Offer a very short reply. 3.62e+08. What is the difference between the Cost (current US$) of CO2 damage in 1994 and the Cost (current US$) of Minerals in 1995?
Your answer should be very brief. 9.07e+07. What is the difference between the Cost (current US$) in CO2 damage in 1994 and the Cost (current US$) in Energy in 1995?
Provide a short and direct response. -2.82e+08. What is the difference between the Cost (current US$) in CO2 damage in 1994 and the Cost (current US$) in Forest in 1995?
Ensure brevity in your answer.  4.60e+07. What is the difference between the Cost (current US$) in Minerals in 1994 and the Cost (current US$) in Energy in 1995?
Your answer should be compact. -3.72e+08. What is the difference between the Cost (current US$) in Minerals in 1994 and the Cost (current US$) in Forest in 1995?
Your answer should be compact. -4.45e+07. What is the difference between the Cost (current US$) of Energy in 1994 and the Cost (current US$) of Forest in 1995?
Give a very brief answer. 3.13e+08. What is the average Cost (current US$) of CO2 damage per year?
Keep it short and to the point. 7.44e+07. What is the average Cost (current US$) of Minerals per year?
Keep it short and to the point. 2.91e+06. What is the average Cost (current US$) in Energy per year?
Offer a terse response. 3.64e+08. What is the average Cost (current US$) in Forest per year?
Your answer should be very brief. 4.57e+07. In the year 1987, what is the difference between the Cost (current US$) in CO2 damage and Cost (current US$) in Minerals?
Ensure brevity in your answer.  4.97e+07. In the year 1987, what is the difference between the Cost (current US$) in CO2 damage and Cost (current US$) in Energy?
Your response must be concise. -2.33e+08. In the year 1987, what is the difference between the Cost (current US$) in CO2 damage and Cost (current US$) in Forest?
Offer a terse response. 1.39e+07. In the year 1987, what is the difference between the Cost (current US$) of Minerals and Cost (current US$) of Energy?
Ensure brevity in your answer.  -2.83e+08. In the year 1987, what is the difference between the Cost (current US$) of Minerals and Cost (current US$) of Forest?
Offer a terse response. -3.58e+07. In the year 1987, what is the difference between the Cost (current US$) in Energy and Cost (current US$) in Forest?
Make the answer very short. 2.47e+08. In the year 1988, what is the difference between the Cost (current US$) in CO2 damage and Cost (current US$) in Minerals?
Keep it short and to the point. 4.72e+07. In the year 1988, what is the difference between the Cost (current US$) in CO2 damage and Cost (current US$) in Energy?
Offer a very short reply. -1.50e+08. In the year 1988, what is the difference between the Cost (current US$) of CO2 damage and Cost (current US$) of Forest?
Give a very brief answer. 1.55e+07. In the year 1988, what is the difference between the Cost (current US$) of Minerals and Cost (current US$) of Energy?
Provide a short and direct response. -1.97e+08. In the year 1988, what is the difference between the Cost (current US$) of Minerals and Cost (current US$) of Forest?
Offer a very short reply. -3.17e+07. In the year 1988, what is the difference between the Cost (current US$) of Energy and Cost (current US$) of Forest?
Offer a terse response. 1.65e+08. In the year 1989, what is the difference between the Cost (current US$) in CO2 damage and Cost (current US$) in Minerals?
Offer a terse response. 5.48e+07. In the year 1989, what is the difference between the Cost (current US$) of CO2 damage and Cost (current US$) of Energy?
Your answer should be compact. -1.97e+08. In the year 1989, what is the difference between the Cost (current US$) in CO2 damage and Cost (current US$) in Forest?
Your answer should be very brief. 2.09e+07. In the year 1989, what is the difference between the Cost (current US$) of Minerals and Cost (current US$) of Energy?
Provide a succinct answer. -2.52e+08. In the year 1989, what is the difference between the Cost (current US$) of Minerals and Cost (current US$) of Forest?
Ensure brevity in your answer.  -3.39e+07. In the year 1989, what is the difference between the Cost (current US$) of Energy and Cost (current US$) of Forest?
Offer a very short reply. 2.18e+08. In the year 1990, what is the difference between the Cost (current US$) of CO2 damage and Cost (current US$) of Minerals?
Offer a terse response. 6.10e+07. In the year 1990, what is the difference between the Cost (current US$) in CO2 damage and Cost (current US$) in Energy?
Give a very brief answer. -2.50e+08. In the year 1990, what is the difference between the Cost (current US$) of CO2 damage and Cost (current US$) of Forest?
Your response must be concise. 1.69e+07. In the year 1990, what is the difference between the Cost (current US$) in Minerals and Cost (current US$) in Energy?
Offer a terse response. -3.11e+08. In the year 1990, what is the difference between the Cost (current US$) in Minerals and Cost (current US$) in Forest?
Offer a terse response. -4.41e+07. In the year 1990, what is the difference between the Cost (current US$) of Energy and Cost (current US$) of Forest?
Make the answer very short. 2.67e+08. In the year 1991, what is the difference between the Cost (current US$) in CO2 damage and Cost (current US$) in Minerals?
Offer a very short reply. 7.86e+07. In the year 1991, what is the difference between the Cost (current US$) of CO2 damage and Cost (current US$) of Energy?
Your response must be concise. -4.59e+08. In the year 1991, what is the difference between the Cost (current US$) of CO2 damage and Cost (current US$) of Forest?
Give a very brief answer. 2.57e+07. In the year 1991, what is the difference between the Cost (current US$) of Minerals and Cost (current US$) of Energy?
Keep it short and to the point. -5.38e+08. In the year 1991, what is the difference between the Cost (current US$) of Minerals and Cost (current US$) of Forest?
Ensure brevity in your answer.  -5.29e+07. In the year 1991, what is the difference between the Cost (current US$) of Energy and Cost (current US$) of Forest?
Keep it short and to the point. 4.85e+08. In the year 1992, what is the difference between the Cost (current US$) in CO2 damage and Cost (current US$) in Minerals?
Give a very brief answer. 7.88e+07. In the year 1992, what is the difference between the Cost (current US$) in CO2 damage and Cost (current US$) in Energy?
Give a very brief answer. -4.54e+08. In the year 1992, what is the difference between the Cost (current US$) in CO2 damage and Cost (current US$) in Forest?
Your answer should be very brief. 2.01e+07. In the year 1992, what is the difference between the Cost (current US$) of Minerals and Cost (current US$) of Energy?
Ensure brevity in your answer.  -5.33e+08. In the year 1992, what is the difference between the Cost (current US$) of Minerals and Cost (current US$) of Forest?
Make the answer very short. -5.87e+07. In the year 1992, what is the difference between the Cost (current US$) in Energy and Cost (current US$) in Forest?
Your response must be concise. 4.74e+08. In the year 1993, what is the difference between the Cost (current US$) of CO2 damage and Cost (current US$) of Minerals?
Offer a terse response. 9.06e+07. In the year 1993, what is the difference between the Cost (current US$) in CO2 damage and Cost (current US$) in Energy?
Make the answer very short. -3.15e+08. In the year 1993, what is the difference between the Cost (current US$) in CO2 damage and Cost (current US$) in Forest?
Give a very brief answer. 4.65e+07. In the year 1993, what is the difference between the Cost (current US$) of Minerals and Cost (current US$) of Energy?
Give a very brief answer. -4.06e+08. In the year 1993, what is the difference between the Cost (current US$) of Minerals and Cost (current US$) of Forest?
Provide a succinct answer. -4.41e+07. In the year 1993, what is the difference between the Cost (current US$) of Energy and Cost (current US$) of Forest?
Your response must be concise. 3.62e+08. In the year 1994, what is the difference between the Cost (current US$) in CO2 damage and Cost (current US$) in Minerals?
Make the answer very short. 9.06e+07. In the year 1994, what is the difference between the Cost (current US$) in CO2 damage and Cost (current US$) in Energy?
Your answer should be very brief. -2.67e+08. In the year 1994, what is the difference between the Cost (current US$) in CO2 damage and Cost (current US$) in Forest?
Keep it short and to the point. 5.08e+07. In the year 1994, what is the difference between the Cost (current US$) of Minerals and Cost (current US$) of Energy?
Provide a succinct answer. -3.58e+08. In the year 1994, what is the difference between the Cost (current US$) of Minerals and Cost (current US$) of Forest?
Your answer should be compact. -3.97e+07. In the year 1994, what is the difference between the Cost (current US$) in Energy and Cost (current US$) in Forest?
Make the answer very short. 3.18e+08. In the year 1995, what is the difference between the Cost (current US$) in CO2 damage and Cost (current US$) in Minerals?
Provide a succinct answer. 9.25e+07. In the year 1995, what is the difference between the Cost (current US$) of CO2 damage and Cost (current US$) of Energy?
Keep it short and to the point. -2.80e+08. In the year 1995, what is the difference between the Cost (current US$) in CO2 damage and Cost (current US$) in Forest?
Offer a very short reply. 4.78e+07. In the year 1995, what is the difference between the Cost (current US$) of Minerals and Cost (current US$) of Energy?
Give a very brief answer. -3.73e+08. In the year 1995, what is the difference between the Cost (current US$) of Minerals and Cost (current US$) of Forest?
Provide a succinct answer. -4.47e+07. In the year 1995, what is the difference between the Cost (current US$) in Energy and Cost (current US$) in Forest?
Your response must be concise. 3.28e+08. What is the ratio of the Cost (current US$) in CO2 damage in 1987 to that in 1988?
Keep it short and to the point. 0.9. What is the ratio of the Cost (current US$) in Minerals in 1987 to that in 1988?
Your answer should be compact. 0.07. What is the ratio of the Cost (current US$) in Energy in 1987 to that in 1988?
Offer a very short reply. 1.38. What is the ratio of the Cost (current US$) in Forest in 1987 to that in 1988?
Give a very brief answer. 0.9. What is the ratio of the Cost (current US$) in CO2 damage in 1987 to that in 1989?
Your answer should be very brief. 0.81. What is the ratio of the Cost (current US$) in Minerals in 1987 to that in 1989?
Your response must be concise. 0.08. What is the ratio of the Cost (current US$) of Energy in 1987 to that in 1989?
Ensure brevity in your answer.  1.09. What is the ratio of the Cost (current US$) in Forest in 1987 to that in 1989?
Offer a very short reply. 0.88. What is the ratio of the Cost (current US$) of CO2 damage in 1987 to that in 1990?
Make the answer very short. 0.77. What is the ratio of the Cost (current US$) in Minerals in 1987 to that in 1990?
Your answer should be compact. 0.12. What is the ratio of the Cost (current US$) of Energy in 1987 to that in 1990?
Keep it short and to the point. 0.9. What is the ratio of the Cost (current US$) in Forest in 1987 to that in 1990?
Keep it short and to the point. 0.75. What is the ratio of the Cost (current US$) of CO2 damage in 1987 to that in 1991?
Your response must be concise. 0.63. What is the ratio of the Cost (current US$) in Minerals in 1987 to that in 1991?
Provide a succinct answer. 0.39. What is the ratio of the Cost (current US$) in Energy in 1987 to that in 1991?
Your answer should be compact. 0.53. What is the ratio of the Cost (current US$) in Forest in 1987 to that in 1991?
Give a very brief answer. 0.67. What is the ratio of the Cost (current US$) in CO2 damage in 1987 to that in 1992?
Offer a terse response. 0.63. What is the ratio of the Cost (current US$) in Minerals in 1987 to that in 1992?
Provide a succinct answer. 0.38. What is the ratio of the Cost (current US$) of Energy in 1987 to that in 1992?
Your answer should be very brief. 0.53. What is the ratio of the Cost (current US$) in Forest in 1987 to that in 1992?
Your response must be concise. 0.6. What is the ratio of the Cost (current US$) in CO2 damage in 1987 to that in 1993?
Keep it short and to the point. 0.55. What is the ratio of the Cost (current US$) of Minerals in 1987 to that in 1993?
Offer a terse response. 0.71. What is the ratio of the Cost (current US$) of Energy in 1987 to that in 1993?
Your answer should be compact. 0.7. What is the ratio of the Cost (current US$) in Forest in 1987 to that in 1993?
Make the answer very short. 0.81. What is the ratio of the Cost (current US$) in CO2 damage in 1987 to that in 1994?
Give a very brief answer. 0.55. What is the ratio of the Cost (current US$) of Minerals in 1987 to that in 1994?
Offer a very short reply. 0.88. What is the ratio of the Cost (current US$) in Energy in 1987 to that in 1994?
Provide a succinct answer. 0.79. What is the ratio of the Cost (current US$) of Forest in 1987 to that in 1994?
Provide a succinct answer. 0.9. What is the ratio of the Cost (current US$) of CO2 damage in 1987 to that in 1995?
Keep it short and to the point. 0.54. What is the ratio of the Cost (current US$) of Minerals in 1987 to that in 1995?
Your answer should be very brief. 1.12. What is the ratio of the Cost (current US$) in Energy in 1987 to that in 1995?
Offer a terse response. 0.76. What is the ratio of the Cost (current US$) of Forest in 1987 to that in 1995?
Offer a terse response. 0.8. What is the ratio of the Cost (current US$) of CO2 damage in 1988 to that in 1989?
Your answer should be very brief. 0.9. What is the ratio of the Cost (current US$) of Minerals in 1988 to that in 1989?
Keep it short and to the point. 1.15. What is the ratio of the Cost (current US$) in Energy in 1988 to that in 1989?
Your answer should be very brief. 0.79. What is the ratio of the Cost (current US$) in Forest in 1988 to that in 1989?
Give a very brief answer. 0.97. What is the ratio of the Cost (current US$) in CO2 damage in 1988 to that in 1990?
Ensure brevity in your answer.  0.85. What is the ratio of the Cost (current US$) in Minerals in 1988 to that in 1990?
Keep it short and to the point. 1.89. What is the ratio of the Cost (current US$) in Energy in 1988 to that in 1990?
Provide a short and direct response. 0.65. What is the ratio of the Cost (current US$) in Forest in 1988 to that in 1990?
Ensure brevity in your answer.  0.83. What is the ratio of the Cost (current US$) of CO2 damage in 1988 to that in 1991?
Make the answer very short. 0.7. What is the ratio of the Cost (current US$) of Minerals in 1988 to that in 1991?
Provide a short and direct response. 6. What is the ratio of the Cost (current US$) of Energy in 1988 to that in 1991?
Your answer should be compact. 0.38. What is the ratio of the Cost (current US$) in Forest in 1988 to that in 1991?
Give a very brief answer. 0.74. What is the ratio of the Cost (current US$) of CO2 damage in 1988 to that in 1992?
Provide a short and direct response. 0.7. What is the ratio of the Cost (current US$) in Minerals in 1988 to that in 1992?
Offer a terse response. 5.77. What is the ratio of the Cost (current US$) of Energy in 1988 to that in 1992?
Make the answer very short. 0.38. What is the ratio of the Cost (current US$) of Forest in 1988 to that in 1992?
Provide a short and direct response. 0.67. What is the ratio of the Cost (current US$) of CO2 damage in 1988 to that in 1993?
Provide a succinct answer. 0.61. What is the ratio of the Cost (current US$) of Minerals in 1988 to that in 1993?
Your answer should be very brief. 10.87. What is the ratio of the Cost (current US$) of Energy in 1988 to that in 1993?
Keep it short and to the point. 0.51. What is the ratio of the Cost (current US$) in Forest in 1988 to that in 1993?
Provide a succinct answer. 0.9. What is the ratio of the Cost (current US$) of CO2 damage in 1988 to that in 1994?
Provide a short and direct response. 0.61. What is the ratio of the Cost (current US$) in Minerals in 1988 to that in 1994?
Make the answer very short. 13.36. What is the ratio of the Cost (current US$) in Energy in 1988 to that in 1994?
Give a very brief answer. 0.57. What is the ratio of the Cost (current US$) of CO2 damage in 1988 to that in 1995?
Ensure brevity in your answer.  0.6. What is the ratio of the Cost (current US$) of Minerals in 1988 to that in 1995?
Offer a terse response. 17.01. What is the ratio of the Cost (current US$) in Energy in 1988 to that in 1995?
Ensure brevity in your answer.  0.55. What is the ratio of the Cost (current US$) of Forest in 1988 to that in 1995?
Your response must be concise. 0.89. What is the ratio of the Cost (current US$) in CO2 damage in 1989 to that in 1990?
Make the answer very short. 0.95. What is the ratio of the Cost (current US$) in Minerals in 1989 to that in 1990?
Your response must be concise. 1.65. What is the ratio of the Cost (current US$) in Energy in 1989 to that in 1990?
Make the answer very short. 0.82. What is the ratio of the Cost (current US$) in Forest in 1989 to that in 1990?
Provide a succinct answer. 0.85. What is the ratio of the Cost (current US$) in CO2 damage in 1989 to that in 1991?
Provide a short and direct response. 0.78. What is the ratio of the Cost (current US$) of Minerals in 1989 to that in 1991?
Make the answer very short. 5.24. What is the ratio of the Cost (current US$) of Energy in 1989 to that in 1991?
Your answer should be very brief. 0.48. What is the ratio of the Cost (current US$) of Forest in 1989 to that in 1991?
Give a very brief answer. 0.76. What is the ratio of the Cost (current US$) in CO2 damage in 1989 to that in 1992?
Keep it short and to the point. 0.78. What is the ratio of the Cost (current US$) of Minerals in 1989 to that in 1992?
Give a very brief answer. 5.03. What is the ratio of the Cost (current US$) in Energy in 1989 to that in 1992?
Your response must be concise. 0.48. What is the ratio of the Cost (current US$) of Forest in 1989 to that in 1992?
Keep it short and to the point. 0.69. What is the ratio of the Cost (current US$) in CO2 damage in 1989 to that in 1993?
Make the answer very short. 0.68. What is the ratio of the Cost (current US$) of Minerals in 1989 to that in 1993?
Your answer should be very brief. 9.48. What is the ratio of the Cost (current US$) of Energy in 1989 to that in 1993?
Offer a terse response. 0.64. What is the ratio of the Cost (current US$) in Forest in 1989 to that in 1993?
Keep it short and to the point. 0.92. What is the ratio of the Cost (current US$) in CO2 damage in 1989 to that in 1994?
Your answer should be very brief. 0.68. What is the ratio of the Cost (current US$) in Minerals in 1989 to that in 1994?
Make the answer very short. 11.66. What is the ratio of the Cost (current US$) in Energy in 1989 to that in 1994?
Provide a short and direct response. 0.72. What is the ratio of the Cost (current US$) of Forest in 1989 to that in 1994?
Your answer should be very brief. 1.03. What is the ratio of the Cost (current US$) in CO2 damage in 1989 to that in 1995?
Keep it short and to the point. 0.67. What is the ratio of the Cost (current US$) of Minerals in 1989 to that in 1995?
Make the answer very short. 14.85. What is the ratio of the Cost (current US$) of Energy in 1989 to that in 1995?
Give a very brief answer. 0.69. What is the ratio of the Cost (current US$) of Forest in 1989 to that in 1995?
Keep it short and to the point. 0.92. What is the ratio of the Cost (current US$) of CO2 damage in 1990 to that in 1991?
Offer a very short reply. 0.82. What is the ratio of the Cost (current US$) in Minerals in 1990 to that in 1991?
Keep it short and to the point. 3.18. What is the ratio of the Cost (current US$) in Energy in 1990 to that in 1991?
Make the answer very short. 0.58. What is the ratio of the Cost (current US$) of Forest in 1990 to that in 1991?
Offer a very short reply. 0.9. What is the ratio of the Cost (current US$) of CO2 damage in 1990 to that in 1992?
Make the answer very short. 0.82. What is the ratio of the Cost (current US$) of Minerals in 1990 to that in 1992?
Give a very brief answer. 3.06. What is the ratio of the Cost (current US$) of Energy in 1990 to that in 1992?
Provide a succinct answer. 0.59. What is the ratio of the Cost (current US$) in Forest in 1990 to that in 1992?
Your answer should be very brief. 0.81. What is the ratio of the Cost (current US$) in CO2 damage in 1990 to that in 1993?
Keep it short and to the point. 0.72. What is the ratio of the Cost (current US$) of Minerals in 1990 to that in 1993?
Give a very brief answer. 5.76. What is the ratio of the Cost (current US$) in Energy in 1990 to that in 1993?
Ensure brevity in your answer.  0.77. What is the ratio of the Cost (current US$) in Forest in 1990 to that in 1993?
Give a very brief answer. 1.08. What is the ratio of the Cost (current US$) of CO2 damage in 1990 to that in 1994?
Keep it short and to the point. 0.72. What is the ratio of the Cost (current US$) in Minerals in 1990 to that in 1994?
Offer a very short reply. 7.08. What is the ratio of the Cost (current US$) in Energy in 1990 to that in 1994?
Provide a short and direct response. 0.88. What is the ratio of the Cost (current US$) in Forest in 1990 to that in 1994?
Your answer should be compact. 1.21. What is the ratio of the Cost (current US$) of CO2 damage in 1990 to that in 1995?
Provide a succinct answer. 0.7. What is the ratio of the Cost (current US$) in Minerals in 1990 to that in 1995?
Offer a very short reply. 9.02. What is the ratio of the Cost (current US$) of Energy in 1990 to that in 1995?
Make the answer very short. 0.85. What is the ratio of the Cost (current US$) in Forest in 1990 to that in 1995?
Make the answer very short. 1.08. What is the ratio of the Cost (current US$) in Minerals in 1991 to that in 1992?
Ensure brevity in your answer.  0.96. What is the ratio of the Cost (current US$) in Energy in 1991 to that in 1992?
Offer a very short reply. 1.01. What is the ratio of the Cost (current US$) in Forest in 1991 to that in 1992?
Your answer should be compact. 0.9. What is the ratio of the Cost (current US$) in CO2 damage in 1991 to that in 1993?
Offer a terse response. 0.88. What is the ratio of the Cost (current US$) in Minerals in 1991 to that in 1993?
Offer a very short reply. 1.81. What is the ratio of the Cost (current US$) of Energy in 1991 to that in 1993?
Your answer should be very brief. 1.33. What is the ratio of the Cost (current US$) in Forest in 1991 to that in 1993?
Give a very brief answer. 1.21. What is the ratio of the Cost (current US$) in CO2 damage in 1991 to that in 1994?
Provide a short and direct response. 0.88. What is the ratio of the Cost (current US$) in Minerals in 1991 to that in 1994?
Provide a short and direct response. 2.22. What is the ratio of the Cost (current US$) of Energy in 1991 to that in 1994?
Your answer should be very brief. 1.51. What is the ratio of the Cost (current US$) in Forest in 1991 to that in 1994?
Provide a succinct answer. 1.35. What is the ratio of the Cost (current US$) of CO2 damage in 1991 to that in 1995?
Ensure brevity in your answer.  0.86. What is the ratio of the Cost (current US$) of Minerals in 1991 to that in 1995?
Your answer should be very brief. 2.83. What is the ratio of the Cost (current US$) in Energy in 1991 to that in 1995?
Offer a terse response. 1.45. What is the ratio of the Cost (current US$) in Forest in 1991 to that in 1995?
Make the answer very short. 1.2. What is the ratio of the Cost (current US$) of CO2 damage in 1992 to that in 1993?
Make the answer very short. 0.88. What is the ratio of the Cost (current US$) in Minerals in 1992 to that in 1993?
Provide a short and direct response. 1.88. What is the ratio of the Cost (current US$) in Energy in 1992 to that in 1993?
Ensure brevity in your answer.  1.31. What is the ratio of the Cost (current US$) of Forest in 1992 to that in 1993?
Your response must be concise. 1.34. What is the ratio of the Cost (current US$) of CO2 damage in 1992 to that in 1994?
Make the answer very short. 0.88. What is the ratio of the Cost (current US$) in Minerals in 1992 to that in 1994?
Your response must be concise. 2.32. What is the ratio of the Cost (current US$) of Energy in 1992 to that in 1994?
Offer a very short reply. 1.49. What is the ratio of the Cost (current US$) in Forest in 1992 to that in 1994?
Provide a short and direct response. 1.49. What is the ratio of the Cost (current US$) of CO2 damage in 1992 to that in 1995?
Your answer should be compact. 0.86. What is the ratio of the Cost (current US$) in Minerals in 1992 to that in 1995?
Your answer should be compact. 2.95. What is the ratio of the Cost (current US$) of Energy in 1992 to that in 1995?
Offer a terse response. 1.43. What is the ratio of the Cost (current US$) of Forest in 1992 to that in 1995?
Keep it short and to the point. 1.33. What is the ratio of the Cost (current US$) in Minerals in 1993 to that in 1994?
Make the answer very short. 1.23. What is the ratio of the Cost (current US$) of Energy in 1993 to that in 1994?
Offer a terse response. 1.14. What is the ratio of the Cost (current US$) of Forest in 1993 to that in 1994?
Provide a short and direct response. 1.11. What is the ratio of the Cost (current US$) in CO2 damage in 1993 to that in 1995?
Ensure brevity in your answer.  0.98. What is the ratio of the Cost (current US$) of Minerals in 1993 to that in 1995?
Make the answer very short. 1.57. What is the ratio of the Cost (current US$) of Energy in 1993 to that in 1995?
Provide a succinct answer. 1.09. What is the ratio of the Cost (current US$) of Forest in 1993 to that in 1995?
Your answer should be very brief. 0.99. What is the ratio of the Cost (current US$) of CO2 damage in 1994 to that in 1995?
Offer a terse response. 0.98. What is the ratio of the Cost (current US$) in Minerals in 1994 to that in 1995?
Ensure brevity in your answer.  1.27. What is the ratio of the Cost (current US$) of Energy in 1994 to that in 1995?
Give a very brief answer. 0.96. What is the ratio of the Cost (current US$) in Forest in 1994 to that in 1995?
Make the answer very short. 0.89. What is the difference between the highest and the second highest Cost (current US$) in CO2 damage?
Your answer should be compact. 1.61e+06. What is the difference between the highest and the second highest Cost (current US$) in Minerals?
Provide a short and direct response. 1.10e+06. What is the difference between the highest and the second highest Cost (current US$) in Energy?
Ensure brevity in your answer.  5.01e+06. What is the difference between the highest and the second highest Cost (current US$) of Forest?
Your answer should be compact. 5.92e+06. What is the difference between the highest and the lowest Cost (current US$) of CO2 damage?
Offer a terse response. 4.27e+07. What is the difference between the highest and the lowest Cost (current US$) of Minerals?
Your response must be concise. 8.13e+06. What is the difference between the highest and the lowest Cost (current US$) in Energy?
Your answer should be compact. 3.34e+08. What is the difference between the highest and the lowest Cost (current US$) in Forest?
Ensure brevity in your answer.  2.39e+07. 